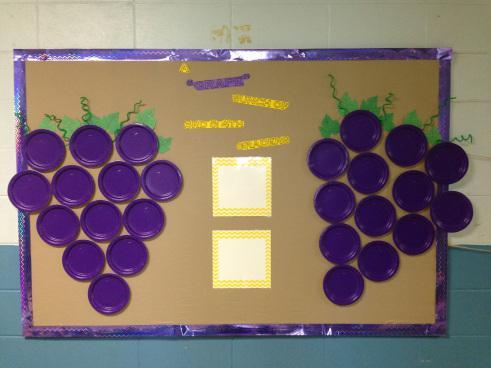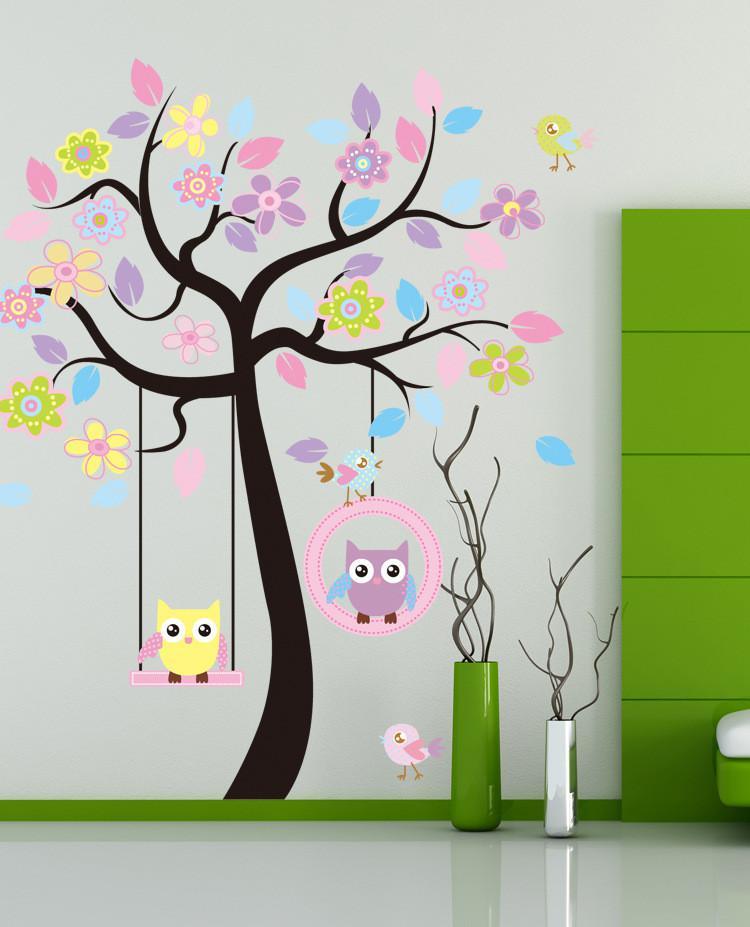The first image is the image on the left, the second image is the image on the right. Assess this claim about the two images: "The right image shows purple balloons used to represent grapes in a cluster, and the left image shows childrens' faces in the center of purple circles.". Correct or not? Answer yes or no. No. The first image is the image on the left, the second image is the image on the right. Examine the images to the left and right. Is the description "Balloons hang from a poster in the image on the right." accurate? Answer yes or no. No. 